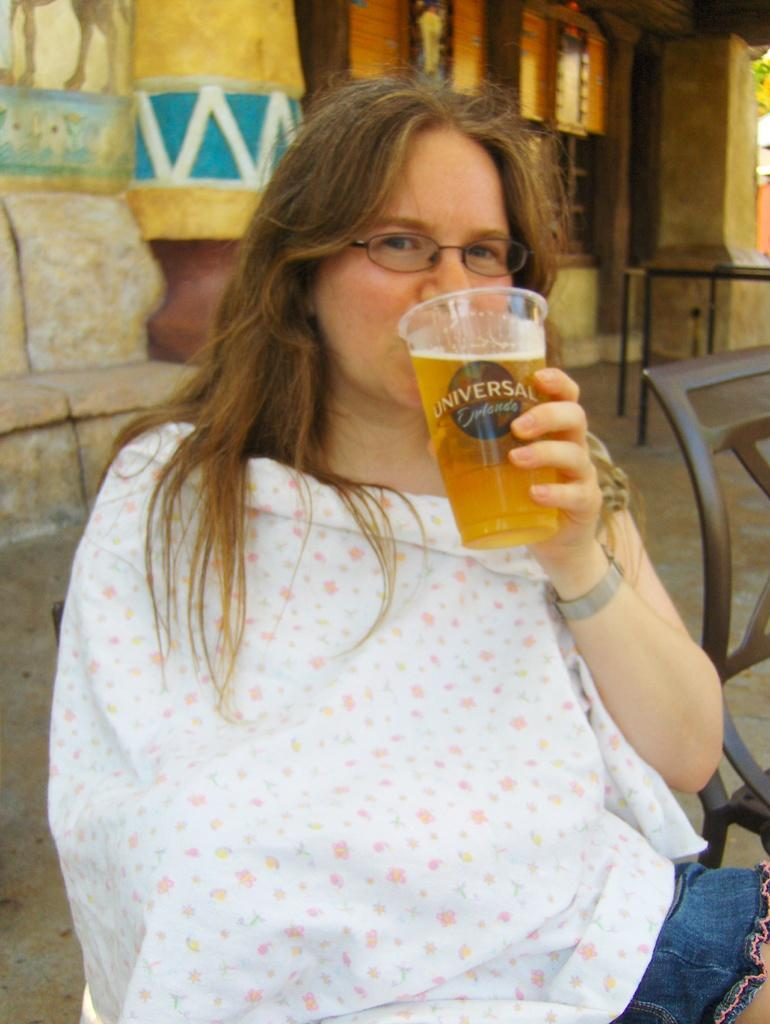What is the woman wearing in the image? The woman is wearing a white dress. Can you describe any accessories the woman is wearing? The woman is wearing spectacles. What is the woman doing in the image? The woman is drinking juice from a glass. What can be seen in the background of the image? There is a building with a window in the background. What piece of furniture is located beside the woman? There is a chair beside the woman. What type of cheese is the woman eating in the image? There is no cheese present in the image; the woman is drinking juice from a glass. What genre of fiction is the woman reading in the image? There is no book or reading material present in the image, so it cannot be determined if the woman is reading fiction or any other genre. 